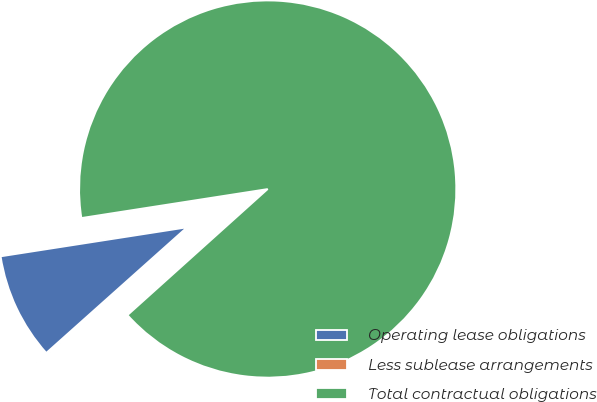<chart> <loc_0><loc_0><loc_500><loc_500><pie_chart><fcel>Operating lease obligations<fcel>Less sublease arrangements<fcel>Total contractual obligations<nl><fcel>9.14%<fcel>0.06%<fcel>90.8%<nl></chart> 